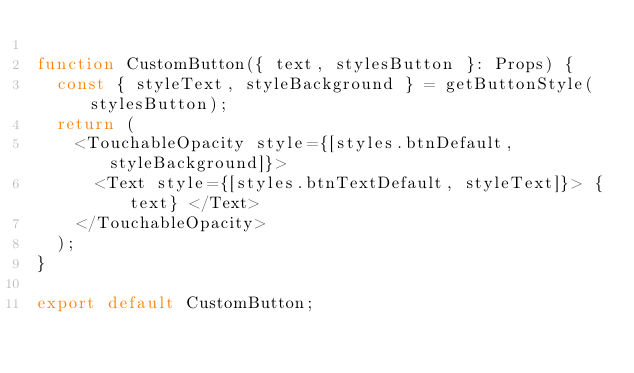<code> <loc_0><loc_0><loc_500><loc_500><_TypeScript_>
function CustomButton({ text, stylesButton }: Props) {
  const { styleText, styleBackground } = getButtonStyle(stylesButton);
  return (
    <TouchableOpacity style={[styles.btnDefault, styleBackground]}>
      <Text style={[styles.btnTextDefault, styleText]}> {text} </Text>
    </TouchableOpacity>
  );
}

export default CustomButton;
</code> 